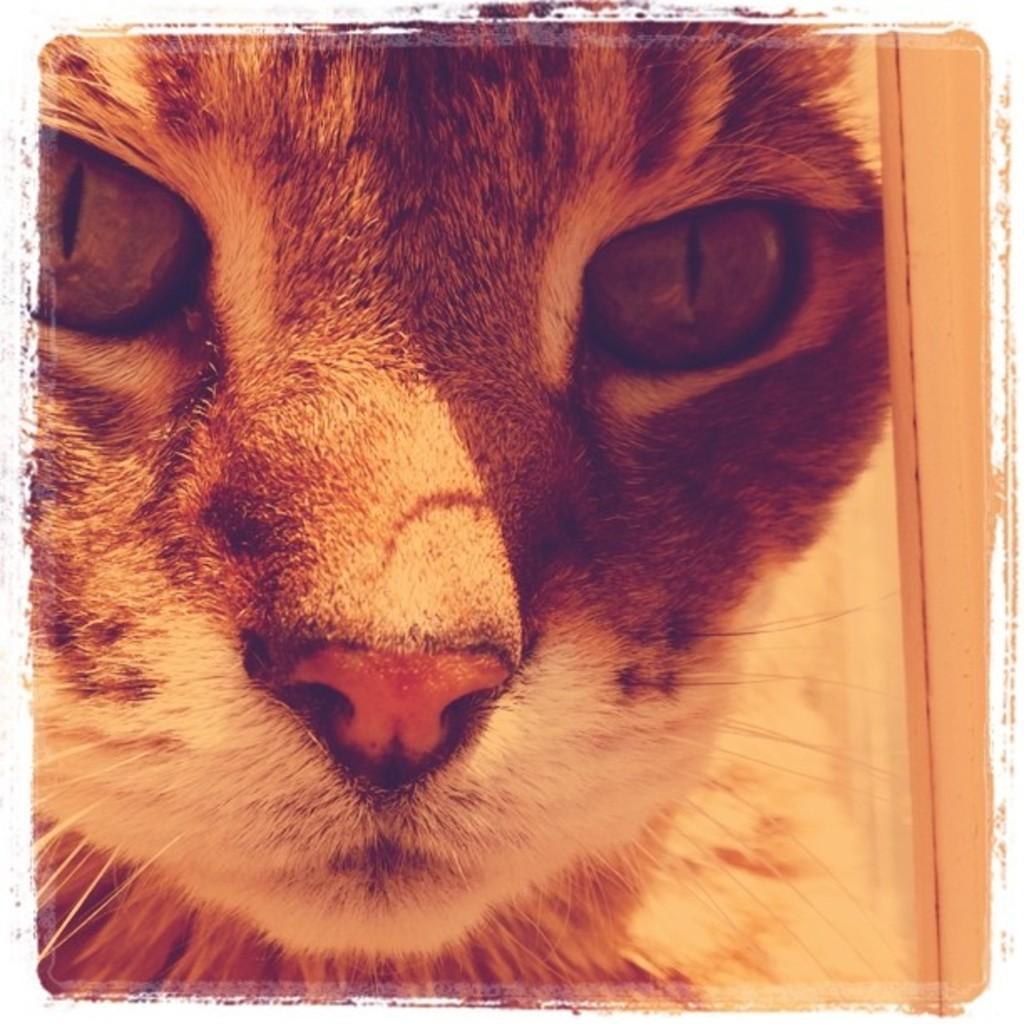How would you summarize this image in a sentence or two? This image consists of a cat. 